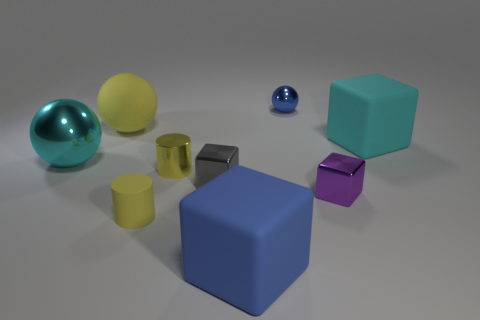There is a big object that is the same color as the tiny shiny ball; what shape is it?
Give a very brief answer. Cube. Are there any big gray metallic things of the same shape as the yellow metallic thing?
Offer a terse response. No. The big rubber thing that is on the right side of the matte block that is on the left side of the tiny blue metal ball is what color?
Offer a terse response. Cyan. Are there more small yellow metallic things than red objects?
Provide a succinct answer. Yes. How many cubes are the same size as the yellow shiny object?
Provide a short and direct response. 2. Is the material of the large yellow thing the same as the block behind the gray metal object?
Provide a succinct answer. Yes. Are there fewer big yellow matte balls than big cubes?
Provide a succinct answer. Yes. Are there any other things that are the same color as the big metallic sphere?
Your response must be concise. Yes. What is the shape of the tiny yellow thing that is made of the same material as the tiny blue object?
Your answer should be compact. Cylinder. How many shiny cubes are on the left side of the metallic ball that is on the right side of the sphere that is on the left side of the big yellow thing?
Your response must be concise. 1. 